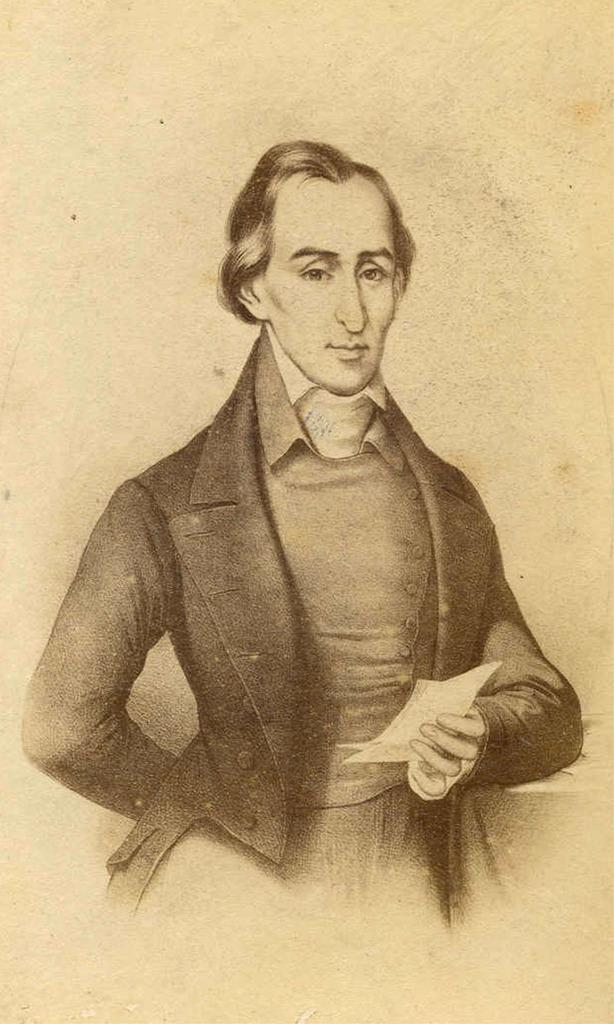Who is present in the image? There is a man in the image. What is the man wearing? The man is wearing a black coat. What is the man holding in the image? The man is holding papers. What is the color of the background in the image? The background in the image is cream-colored. What type of leaf is visible on the man's coat in the image? There is no leaf visible on the man's coat in the image. 